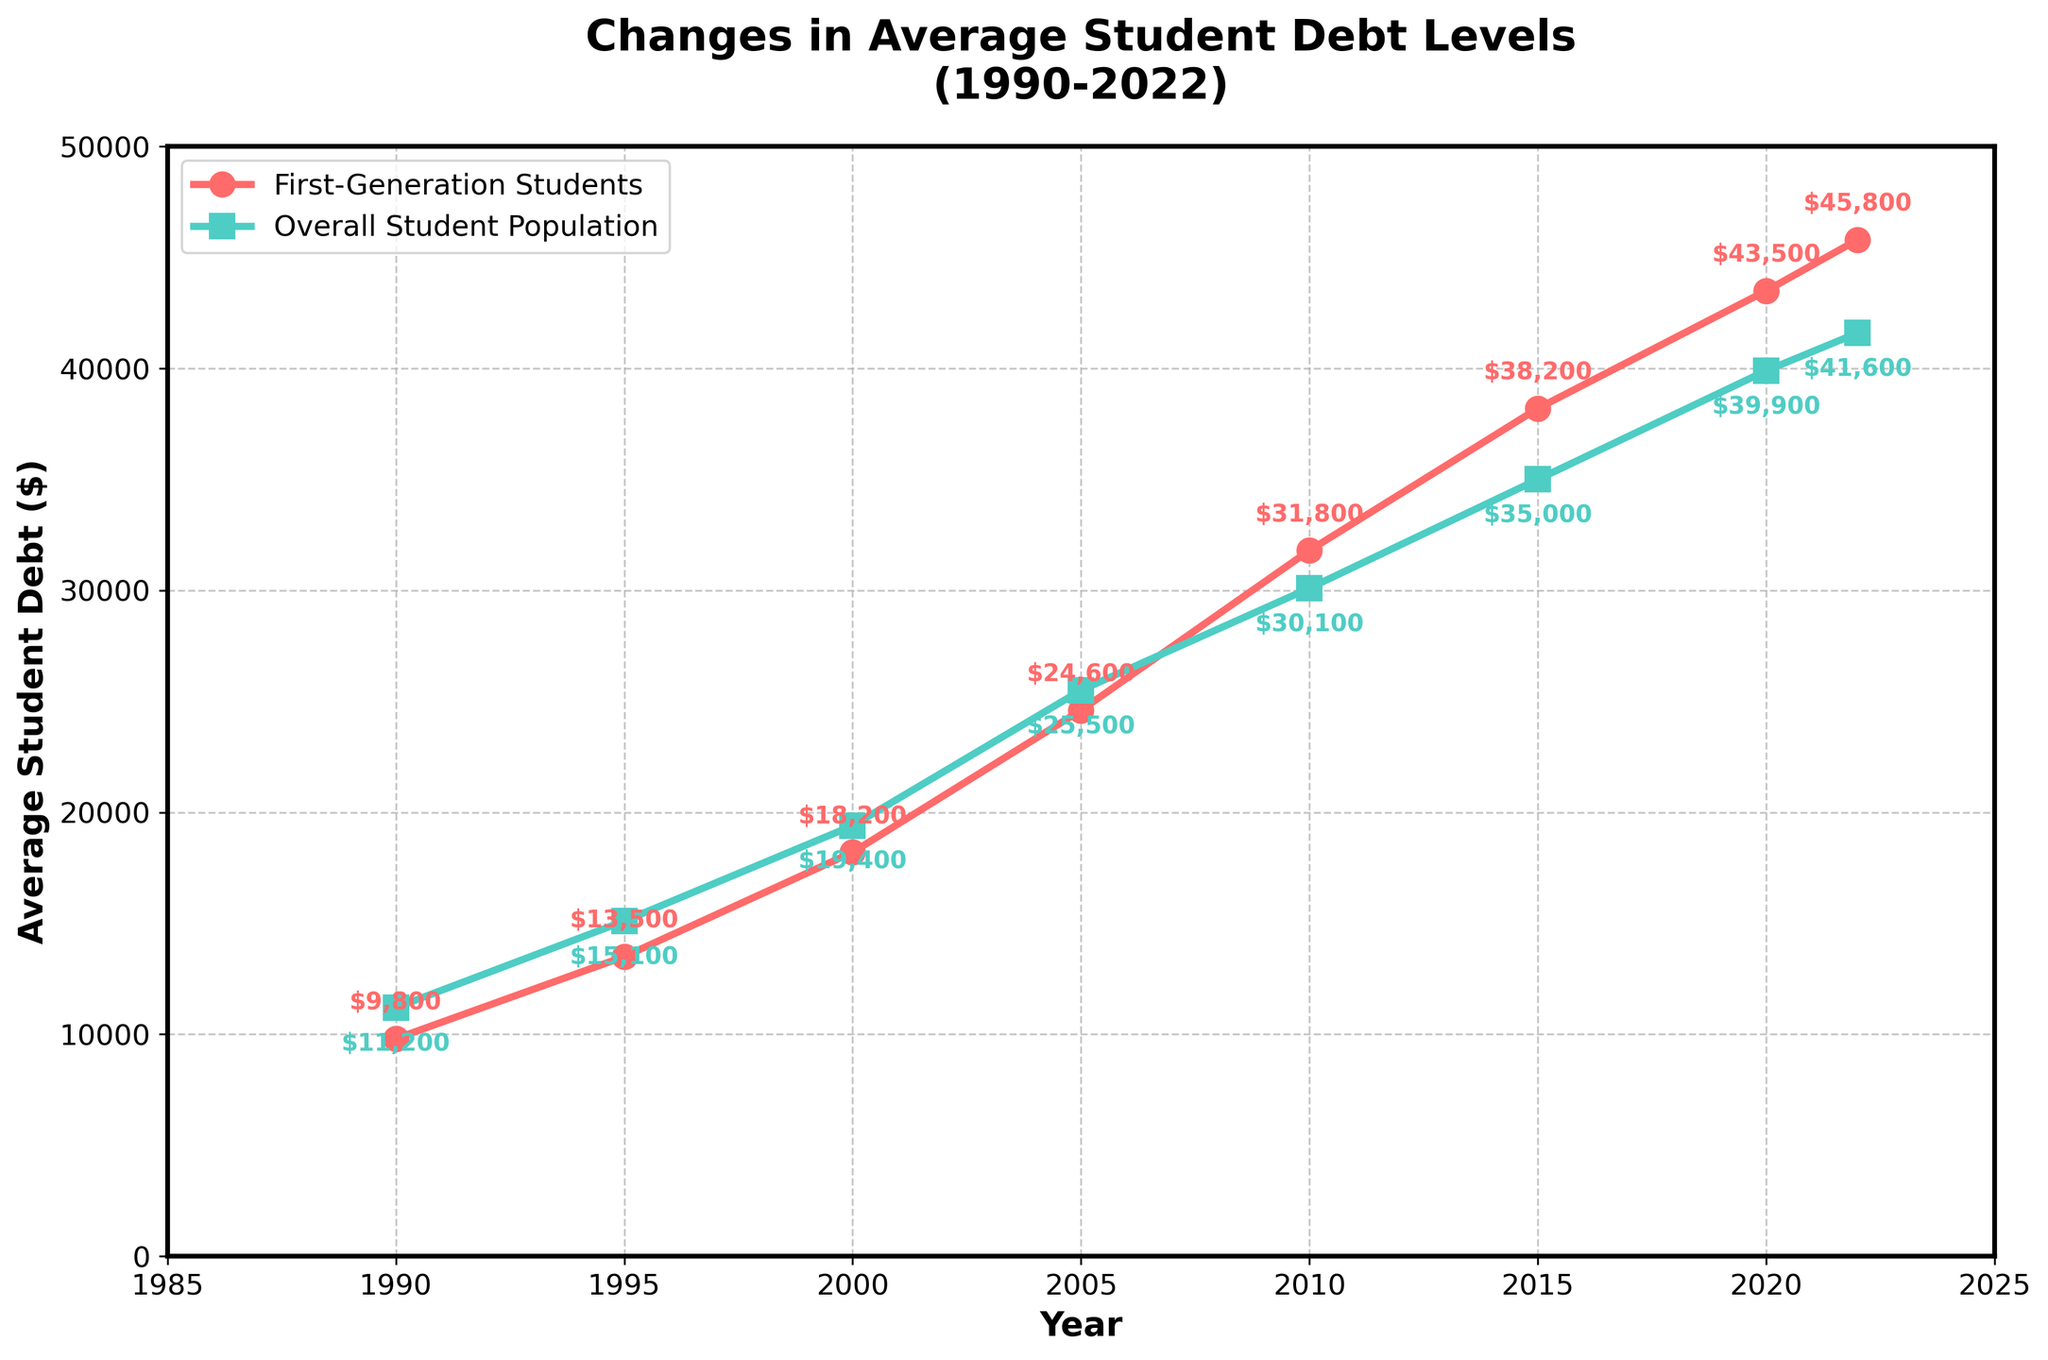What is the average student debt for first-generation students in 2022? The graph shows the average student debt for first-generation students in 2022 is $45,800.
Answer: $45,800 What is the difference in student debt between the first-generation students and the overall student population in 1990? The debt levels in 1990 are $9,800 for first-generation students and $11,200 for the overall population. The difference is $11,200 - $9,800 = $1,400.
Answer: $1,400 During which year did first-generation students experience the greatest increase in average debt compared to the previous data point? From the data, the greatest increase for first-generation students is between 2000 and 2005 ($24,600 - $18,200 = $6,400).
Answer: 2005 Between 2010 and 2015, which group experienced a higher increase in average student debt? For first-generation students, the increase is $38,200 - $31,800 = $6,400. For the overall student population, the increase is $35,000 - $30,100 = $4,900. Therefore, first-generation students experienced a higher increase.
Answer: First-generation students In what year is the student debt for the overall student population first lower than that of first-generation students? By examining the graph, in 2005, the overall student debt was slightly higher than that of first-generation students and then in 2010, the debt of first-generation students surpasses that of the overall population.
Answer: 2010 What is the overall trend of student debt from 1990 to 2022 for first-generation students? The graph shows a consistent upward trend in student debt for first-generation students, rising from $9,800 in 1990 to $45,800 in 2022.
Answer: Upward Which group has a lesser average student debt level in 2022? In 2022, the graph shows that overall student debt is $41,600, whereas first-generation student debt is $45,800. Therefore, the overall student population has a lesser average debt level.
Answer: Overall student population How much greater is the average student debt for first-generation students compared to the overall population in 2022? In 2022, the average debt for first-generation students is $45,800, and for the overall student population, it is $41,600. The difference is $45,800 - $41,600 = $4,200.
Answer: $4,200 What was the average student debt level for first-generation students in 2000, and how does it compare visually to the overall student debt in the same year? In 2000, the average debt for first-generation students is $18,200, and the graph shows this value with a red line, where the red circle marker is slightly below the turquoise square marker at $19,400 for the overall population.
Answer: $18,200; First-generation debt is lower 